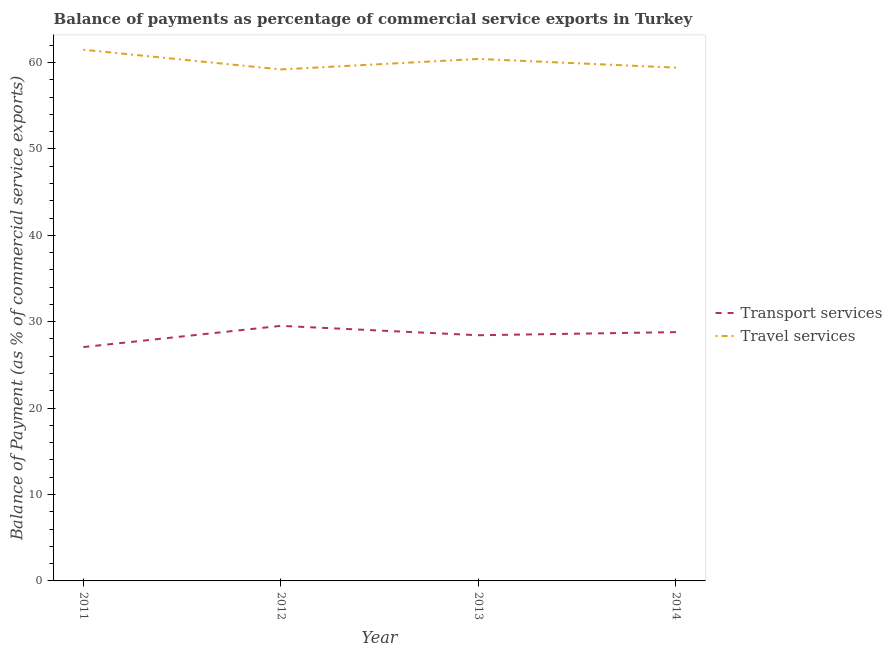How many different coloured lines are there?
Provide a succinct answer. 2. Is the number of lines equal to the number of legend labels?
Your response must be concise. Yes. What is the balance of payments of transport services in 2012?
Give a very brief answer. 29.52. Across all years, what is the maximum balance of payments of travel services?
Your answer should be compact. 61.48. Across all years, what is the minimum balance of payments of transport services?
Your answer should be compact. 27.07. In which year was the balance of payments of transport services maximum?
Make the answer very short. 2012. What is the total balance of payments of transport services in the graph?
Give a very brief answer. 113.82. What is the difference between the balance of payments of travel services in 2011 and that in 2012?
Give a very brief answer. 2.28. What is the difference between the balance of payments of travel services in 2013 and the balance of payments of transport services in 2014?
Your answer should be compact. 31.62. What is the average balance of payments of transport services per year?
Offer a very short reply. 28.45. In the year 2012, what is the difference between the balance of payments of transport services and balance of payments of travel services?
Offer a terse response. -29.68. In how many years, is the balance of payments of transport services greater than 34 %?
Provide a succinct answer. 0. What is the ratio of the balance of payments of travel services in 2012 to that in 2014?
Provide a short and direct response. 1. Is the balance of payments of transport services in 2011 less than that in 2012?
Your answer should be compact. Yes. Is the difference between the balance of payments of transport services in 2012 and 2013 greater than the difference between the balance of payments of travel services in 2012 and 2013?
Your answer should be very brief. Yes. What is the difference between the highest and the second highest balance of payments of transport services?
Your response must be concise. 0.73. What is the difference between the highest and the lowest balance of payments of travel services?
Provide a short and direct response. 2.28. Is the sum of the balance of payments of transport services in 2011 and 2012 greater than the maximum balance of payments of travel services across all years?
Your answer should be compact. No. Does the balance of payments of transport services monotonically increase over the years?
Offer a very short reply. No. How many lines are there?
Offer a terse response. 2. How many years are there in the graph?
Provide a short and direct response. 4. What is the difference between two consecutive major ticks on the Y-axis?
Offer a terse response. 10. Are the values on the major ticks of Y-axis written in scientific E-notation?
Your answer should be compact. No. Where does the legend appear in the graph?
Provide a short and direct response. Center right. How many legend labels are there?
Provide a succinct answer. 2. What is the title of the graph?
Your response must be concise. Balance of payments as percentage of commercial service exports in Turkey. Does "Goods and services" appear as one of the legend labels in the graph?
Ensure brevity in your answer.  No. What is the label or title of the X-axis?
Keep it short and to the point. Year. What is the label or title of the Y-axis?
Ensure brevity in your answer.  Balance of Payment (as % of commercial service exports). What is the Balance of Payment (as % of commercial service exports) in Transport services in 2011?
Give a very brief answer. 27.07. What is the Balance of Payment (as % of commercial service exports) of Travel services in 2011?
Give a very brief answer. 61.48. What is the Balance of Payment (as % of commercial service exports) of Transport services in 2012?
Make the answer very short. 29.52. What is the Balance of Payment (as % of commercial service exports) in Travel services in 2012?
Make the answer very short. 59.2. What is the Balance of Payment (as % of commercial service exports) of Transport services in 2013?
Provide a short and direct response. 28.43. What is the Balance of Payment (as % of commercial service exports) in Travel services in 2013?
Provide a short and direct response. 60.42. What is the Balance of Payment (as % of commercial service exports) in Transport services in 2014?
Ensure brevity in your answer.  28.79. What is the Balance of Payment (as % of commercial service exports) of Travel services in 2014?
Provide a short and direct response. 59.41. Across all years, what is the maximum Balance of Payment (as % of commercial service exports) in Transport services?
Your answer should be very brief. 29.52. Across all years, what is the maximum Balance of Payment (as % of commercial service exports) in Travel services?
Give a very brief answer. 61.48. Across all years, what is the minimum Balance of Payment (as % of commercial service exports) of Transport services?
Keep it short and to the point. 27.07. Across all years, what is the minimum Balance of Payment (as % of commercial service exports) of Travel services?
Your answer should be compact. 59.2. What is the total Balance of Payment (as % of commercial service exports) of Transport services in the graph?
Ensure brevity in your answer.  113.82. What is the total Balance of Payment (as % of commercial service exports) of Travel services in the graph?
Provide a short and direct response. 240.5. What is the difference between the Balance of Payment (as % of commercial service exports) of Transport services in 2011 and that in 2012?
Provide a succinct answer. -2.46. What is the difference between the Balance of Payment (as % of commercial service exports) of Travel services in 2011 and that in 2012?
Offer a terse response. 2.28. What is the difference between the Balance of Payment (as % of commercial service exports) of Transport services in 2011 and that in 2013?
Give a very brief answer. -1.37. What is the difference between the Balance of Payment (as % of commercial service exports) of Travel services in 2011 and that in 2013?
Offer a terse response. 1.06. What is the difference between the Balance of Payment (as % of commercial service exports) in Transport services in 2011 and that in 2014?
Your answer should be compact. -1.73. What is the difference between the Balance of Payment (as % of commercial service exports) in Travel services in 2011 and that in 2014?
Your answer should be compact. 2.07. What is the difference between the Balance of Payment (as % of commercial service exports) of Transport services in 2012 and that in 2013?
Offer a very short reply. 1.09. What is the difference between the Balance of Payment (as % of commercial service exports) of Travel services in 2012 and that in 2013?
Keep it short and to the point. -1.22. What is the difference between the Balance of Payment (as % of commercial service exports) of Transport services in 2012 and that in 2014?
Ensure brevity in your answer.  0.73. What is the difference between the Balance of Payment (as % of commercial service exports) of Travel services in 2012 and that in 2014?
Your response must be concise. -0.21. What is the difference between the Balance of Payment (as % of commercial service exports) of Transport services in 2013 and that in 2014?
Your response must be concise. -0.36. What is the difference between the Balance of Payment (as % of commercial service exports) of Travel services in 2013 and that in 2014?
Provide a short and direct response. 1.01. What is the difference between the Balance of Payment (as % of commercial service exports) in Transport services in 2011 and the Balance of Payment (as % of commercial service exports) in Travel services in 2012?
Provide a succinct answer. -32.13. What is the difference between the Balance of Payment (as % of commercial service exports) in Transport services in 2011 and the Balance of Payment (as % of commercial service exports) in Travel services in 2013?
Ensure brevity in your answer.  -33.35. What is the difference between the Balance of Payment (as % of commercial service exports) in Transport services in 2011 and the Balance of Payment (as % of commercial service exports) in Travel services in 2014?
Offer a terse response. -32.34. What is the difference between the Balance of Payment (as % of commercial service exports) of Transport services in 2012 and the Balance of Payment (as % of commercial service exports) of Travel services in 2013?
Give a very brief answer. -30.89. What is the difference between the Balance of Payment (as % of commercial service exports) of Transport services in 2012 and the Balance of Payment (as % of commercial service exports) of Travel services in 2014?
Offer a terse response. -29.89. What is the difference between the Balance of Payment (as % of commercial service exports) of Transport services in 2013 and the Balance of Payment (as % of commercial service exports) of Travel services in 2014?
Provide a succinct answer. -30.97. What is the average Balance of Payment (as % of commercial service exports) of Transport services per year?
Offer a very short reply. 28.45. What is the average Balance of Payment (as % of commercial service exports) in Travel services per year?
Provide a succinct answer. 60.12. In the year 2011, what is the difference between the Balance of Payment (as % of commercial service exports) in Transport services and Balance of Payment (as % of commercial service exports) in Travel services?
Offer a terse response. -34.41. In the year 2012, what is the difference between the Balance of Payment (as % of commercial service exports) of Transport services and Balance of Payment (as % of commercial service exports) of Travel services?
Your answer should be compact. -29.68. In the year 2013, what is the difference between the Balance of Payment (as % of commercial service exports) of Transport services and Balance of Payment (as % of commercial service exports) of Travel services?
Your answer should be very brief. -31.98. In the year 2014, what is the difference between the Balance of Payment (as % of commercial service exports) in Transport services and Balance of Payment (as % of commercial service exports) in Travel services?
Provide a succinct answer. -30.61. What is the ratio of the Balance of Payment (as % of commercial service exports) of Transport services in 2011 to that in 2012?
Offer a very short reply. 0.92. What is the ratio of the Balance of Payment (as % of commercial service exports) in Transport services in 2011 to that in 2013?
Offer a very short reply. 0.95. What is the ratio of the Balance of Payment (as % of commercial service exports) in Travel services in 2011 to that in 2013?
Give a very brief answer. 1.02. What is the ratio of the Balance of Payment (as % of commercial service exports) in Transport services in 2011 to that in 2014?
Provide a succinct answer. 0.94. What is the ratio of the Balance of Payment (as % of commercial service exports) of Travel services in 2011 to that in 2014?
Ensure brevity in your answer.  1.03. What is the ratio of the Balance of Payment (as % of commercial service exports) in Transport services in 2012 to that in 2013?
Your answer should be compact. 1.04. What is the ratio of the Balance of Payment (as % of commercial service exports) of Travel services in 2012 to that in 2013?
Offer a very short reply. 0.98. What is the ratio of the Balance of Payment (as % of commercial service exports) of Transport services in 2012 to that in 2014?
Offer a terse response. 1.03. What is the ratio of the Balance of Payment (as % of commercial service exports) in Travel services in 2012 to that in 2014?
Your answer should be very brief. 1. What is the ratio of the Balance of Payment (as % of commercial service exports) of Transport services in 2013 to that in 2014?
Provide a short and direct response. 0.99. What is the difference between the highest and the second highest Balance of Payment (as % of commercial service exports) in Transport services?
Your response must be concise. 0.73. What is the difference between the highest and the second highest Balance of Payment (as % of commercial service exports) in Travel services?
Offer a terse response. 1.06. What is the difference between the highest and the lowest Balance of Payment (as % of commercial service exports) in Transport services?
Ensure brevity in your answer.  2.46. What is the difference between the highest and the lowest Balance of Payment (as % of commercial service exports) in Travel services?
Your answer should be very brief. 2.28. 